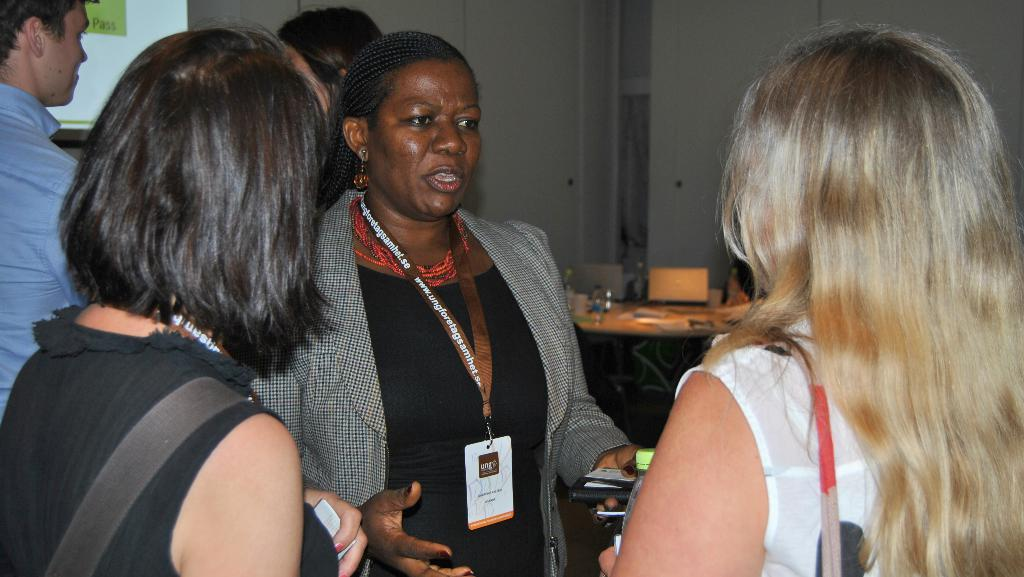How many people are present in the image? There are five persons in the image. What is the main object in the image? There is a table in the image. What items can be seen on the table? There are bottles and laptops on the table. What can be seen in the background of the image? There is a screen and a wall in the background of the image. Can you see any watches on the toes of the persons in the image? There are no watches or toes visible in the image. Is there a tub present in the image? There is no tub present in the image. 